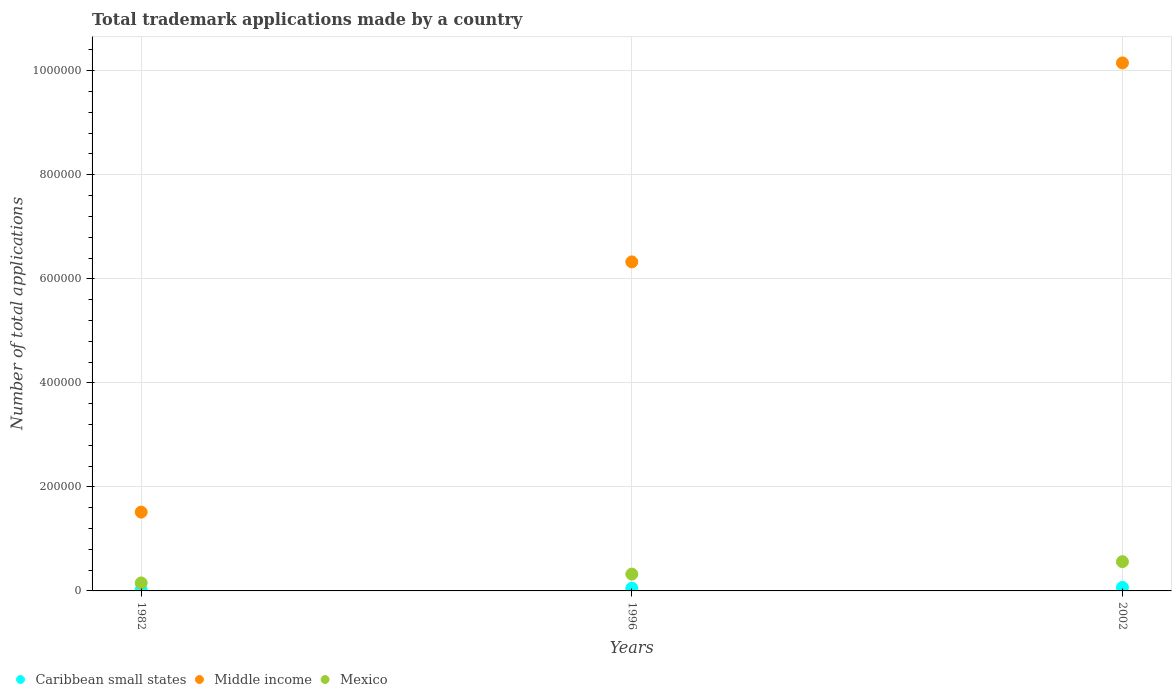How many different coloured dotlines are there?
Your answer should be compact. 3. Is the number of dotlines equal to the number of legend labels?
Offer a terse response. Yes. What is the number of applications made by in Caribbean small states in 1996?
Give a very brief answer. 5173. Across all years, what is the maximum number of applications made by in Middle income?
Provide a short and direct response. 1.02e+06. Across all years, what is the minimum number of applications made by in Middle income?
Offer a very short reply. 1.52e+05. In which year was the number of applications made by in Caribbean small states minimum?
Your response must be concise. 1982. What is the total number of applications made by in Mexico in the graph?
Give a very brief answer. 1.04e+05. What is the difference between the number of applications made by in Mexico in 1982 and that in 2002?
Your response must be concise. -4.09e+04. What is the difference between the number of applications made by in Mexico in 2002 and the number of applications made by in Caribbean small states in 1996?
Provide a short and direct response. 5.11e+04. What is the average number of applications made by in Caribbean small states per year?
Provide a short and direct response. 4815.33. In the year 2002, what is the difference between the number of applications made by in Middle income and number of applications made by in Caribbean small states?
Your answer should be compact. 1.01e+06. In how many years, is the number of applications made by in Caribbean small states greater than 520000?
Offer a very short reply. 0. What is the ratio of the number of applications made by in Mexico in 1982 to that in 1996?
Your answer should be compact. 0.48. What is the difference between the highest and the second highest number of applications made by in Caribbean small states?
Your answer should be very brief. 1606. What is the difference between the highest and the lowest number of applications made by in Mexico?
Keep it short and to the point. 4.09e+04. Is it the case that in every year, the sum of the number of applications made by in Mexico and number of applications made by in Caribbean small states  is greater than the number of applications made by in Middle income?
Keep it short and to the point. No. Does the number of applications made by in Mexico monotonically increase over the years?
Keep it short and to the point. Yes. How many dotlines are there?
Give a very brief answer. 3. Are the values on the major ticks of Y-axis written in scientific E-notation?
Offer a very short reply. No. Does the graph contain any zero values?
Offer a terse response. No. Where does the legend appear in the graph?
Your answer should be very brief. Bottom left. How many legend labels are there?
Keep it short and to the point. 3. What is the title of the graph?
Keep it short and to the point. Total trademark applications made by a country. What is the label or title of the X-axis?
Provide a succinct answer. Years. What is the label or title of the Y-axis?
Your response must be concise. Number of total applications. What is the Number of total applications in Caribbean small states in 1982?
Provide a succinct answer. 2494. What is the Number of total applications of Middle income in 1982?
Offer a terse response. 1.52e+05. What is the Number of total applications of Mexico in 1982?
Provide a short and direct response. 1.54e+04. What is the Number of total applications in Caribbean small states in 1996?
Offer a terse response. 5173. What is the Number of total applications in Middle income in 1996?
Offer a very short reply. 6.33e+05. What is the Number of total applications in Mexico in 1996?
Ensure brevity in your answer.  3.23e+04. What is the Number of total applications of Caribbean small states in 2002?
Provide a short and direct response. 6779. What is the Number of total applications of Middle income in 2002?
Offer a terse response. 1.02e+06. What is the Number of total applications of Mexico in 2002?
Ensure brevity in your answer.  5.62e+04. Across all years, what is the maximum Number of total applications in Caribbean small states?
Make the answer very short. 6779. Across all years, what is the maximum Number of total applications of Middle income?
Offer a terse response. 1.02e+06. Across all years, what is the maximum Number of total applications of Mexico?
Ensure brevity in your answer.  5.62e+04. Across all years, what is the minimum Number of total applications of Caribbean small states?
Offer a very short reply. 2494. Across all years, what is the minimum Number of total applications in Middle income?
Make the answer very short. 1.52e+05. Across all years, what is the minimum Number of total applications of Mexico?
Provide a short and direct response. 1.54e+04. What is the total Number of total applications in Caribbean small states in the graph?
Offer a very short reply. 1.44e+04. What is the total Number of total applications of Middle income in the graph?
Give a very brief answer. 1.80e+06. What is the total Number of total applications in Mexico in the graph?
Make the answer very short. 1.04e+05. What is the difference between the Number of total applications in Caribbean small states in 1982 and that in 1996?
Provide a succinct answer. -2679. What is the difference between the Number of total applications of Middle income in 1982 and that in 1996?
Provide a short and direct response. -4.81e+05. What is the difference between the Number of total applications in Mexico in 1982 and that in 1996?
Make the answer very short. -1.70e+04. What is the difference between the Number of total applications of Caribbean small states in 1982 and that in 2002?
Keep it short and to the point. -4285. What is the difference between the Number of total applications of Middle income in 1982 and that in 2002?
Your response must be concise. -8.64e+05. What is the difference between the Number of total applications in Mexico in 1982 and that in 2002?
Keep it short and to the point. -4.09e+04. What is the difference between the Number of total applications of Caribbean small states in 1996 and that in 2002?
Your response must be concise. -1606. What is the difference between the Number of total applications in Middle income in 1996 and that in 2002?
Provide a succinct answer. -3.83e+05. What is the difference between the Number of total applications in Mexico in 1996 and that in 2002?
Keep it short and to the point. -2.39e+04. What is the difference between the Number of total applications of Caribbean small states in 1982 and the Number of total applications of Middle income in 1996?
Provide a succinct answer. -6.30e+05. What is the difference between the Number of total applications of Caribbean small states in 1982 and the Number of total applications of Mexico in 1996?
Your response must be concise. -2.98e+04. What is the difference between the Number of total applications in Middle income in 1982 and the Number of total applications in Mexico in 1996?
Ensure brevity in your answer.  1.19e+05. What is the difference between the Number of total applications of Caribbean small states in 1982 and the Number of total applications of Middle income in 2002?
Your answer should be very brief. -1.01e+06. What is the difference between the Number of total applications in Caribbean small states in 1982 and the Number of total applications in Mexico in 2002?
Your answer should be compact. -5.37e+04. What is the difference between the Number of total applications in Middle income in 1982 and the Number of total applications in Mexico in 2002?
Give a very brief answer. 9.53e+04. What is the difference between the Number of total applications in Caribbean small states in 1996 and the Number of total applications in Middle income in 2002?
Offer a very short reply. -1.01e+06. What is the difference between the Number of total applications in Caribbean small states in 1996 and the Number of total applications in Mexico in 2002?
Make the answer very short. -5.11e+04. What is the difference between the Number of total applications of Middle income in 1996 and the Number of total applications of Mexico in 2002?
Ensure brevity in your answer.  5.76e+05. What is the average Number of total applications in Caribbean small states per year?
Give a very brief answer. 4815.33. What is the average Number of total applications in Middle income per year?
Make the answer very short. 6.00e+05. What is the average Number of total applications of Mexico per year?
Make the answer very short. 3.46e+04. In the year 1982, what is the difference between the Number of total applications of Caribbean small states and Number of total applications of Middle income?
Provide a succinct answer. -1.49e+05. In the year 1982, what is the difference between the Number of total applications in Caribbean small states and Number of total applications in Mexico?
Your response must be concise. -1.29e+04. In the year 1982, what is the difference between the Number of total applications of Middle income and Number of total applications of Mexico?
Ensure brevity in your answer.  1.36e+05. In the year 1996, what is the difference between the Number of total applications of Caribbean small states and Number of total applications of Middle income?
Give a very brief answer. -6.27e+05. In the year 1996, what is the difference between the Number of total applications in Caribbean small states and Number of total applications in Mexico?
Give a very brief answer. -2.72e+04. In the year 1996, what is the difference between the Number of total applications in Middle income and Number of total applications in Mexico?
Keep it short and to the point. 6.00e+05. In the year 2002, what is the difference between the Number of total applications in Caribbean small states and Number of total applications in Middle income?
Provide a short and direct response. -1.01e+06. In the year 2002, what is the difference between the Number of total applications in Caribbean small states and Number of total applications in Mexico?
Give a very brief answer. -4.95e+04. In the year 2002, what is the difference between the Number of total applications in Middle income and Number of total applications in Mexico?
Keep it short and to the point. 9.59e+05. What is the ratio of the Number of total applications in Caribbean small states in 1982 to that in 1996?
Provide a short and direct response. 0.48. What is the ratio of the Number of total applications in Middle income in 1982 to that in 1996?
Provide a short and direct response. 0.24. What is the ratio of the Number of total applications in Mexico in 1982 to that in 1996?
Offer a terse response. 0.48. What is the ratio of the Number of total applications in Caribbean small states in 1982 to that in 2002?
Make the answer very short. 0.37. What is the ratio of the Number of total applications of Middle income in 1982 to that in 2002?
Your answer should be very brief. 0.15. What is the ratio of the Number of total applications of Mexico in 1982 to that in 2002?
Offer a terse response. 0.27. What is the ratio of the Number of total applications in Caribbean small states in 1996 to that in 2002?
Offer a terse response. 0.76. What is the ratio of the Number of total applications in Middle income in 1996 to that in 2002?
Provide a short and direct response. 0.62. What is the ratio of the Number of total applications in Mexico in 1996 to that in 2002?
Give a very brief answer. 0.57. What is the difference between the highest and the second highest Number of total applications in Caribbean small states?
Offer a terse response. 1606. What is the difference between the highest and the second highest Number of total applications in Middle income?
Provide a succinct answer. 3.83e+05. What is the difference between the highest and the second highest Number of total applications in Mexico?
Your answer should be compact. 2.39e+04. What is the difference between the highest and the lowest Number of total applications in Caribbean small states?
Offer a terse response. 4285. What is the difference between the highest and the lowest Number of total applications of Middle income?
Offer a very short reply. 8.64e+05. What is the difference between the highest and the lowest Number of total applications of Mexico?
Your answer should be compact. 4.09e+04. 